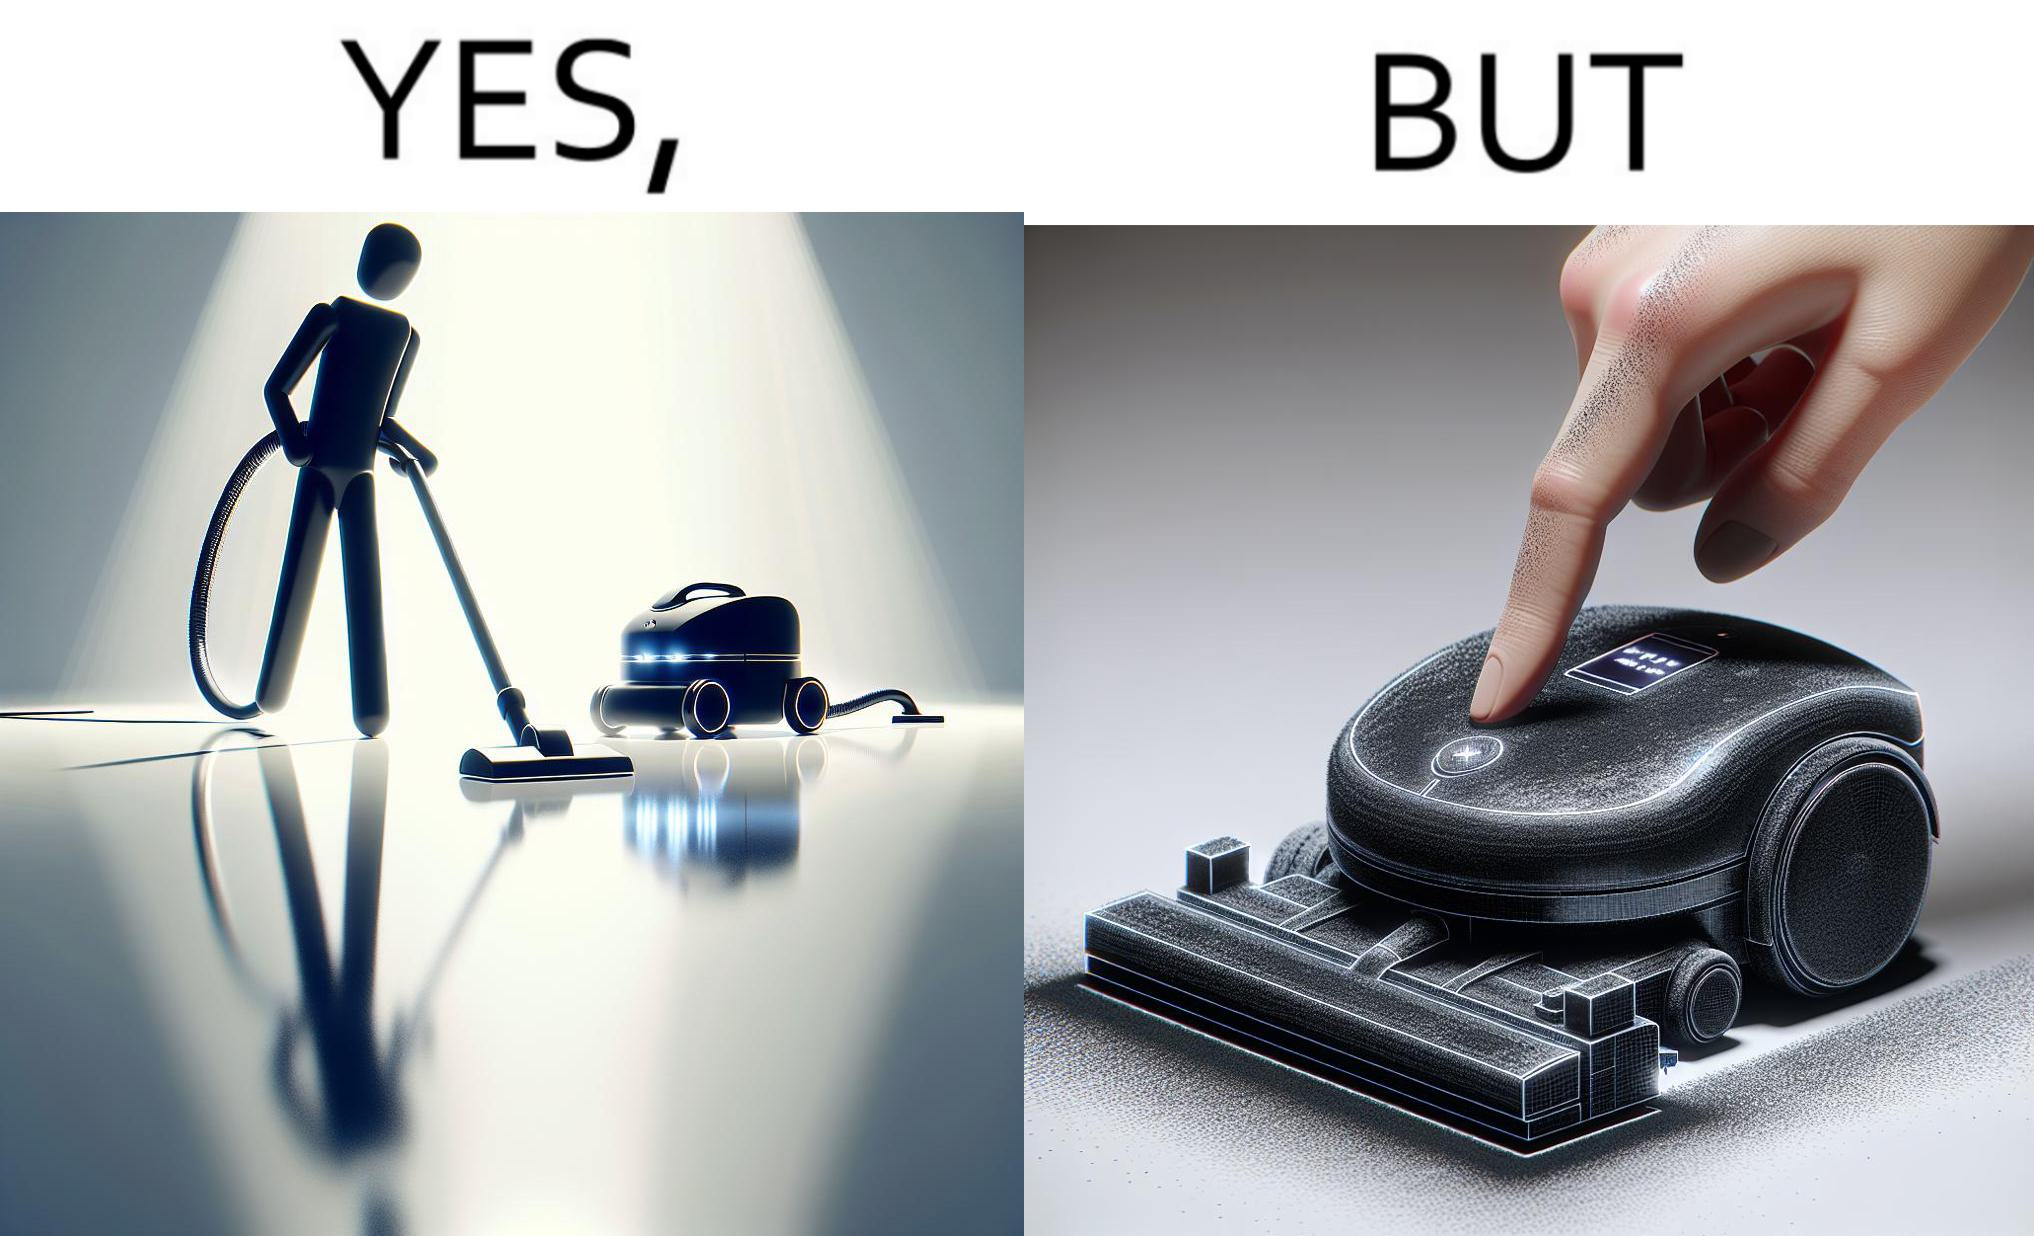What is shown in the left half versus the right half of this image? In the left part of the image: A vacuum cleaning machine that goes around the floor on its own and cleans the floor. Everything  around it looks squeaky clean, and is shining. In the right part of the image: Close up of a vacuum cleaning machine that goes around the floor on its own and cleans the floor. Everything  around it looks squeaky clean, and is shining, but it has a lot of dust on it except one line on it that looks clean. A persons fingertip is visible, and it is covered in dust. 